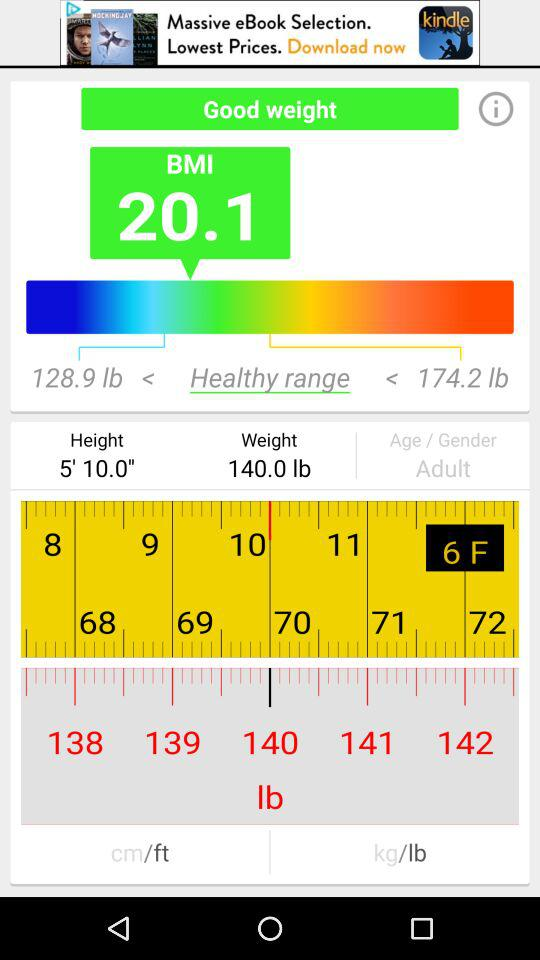What is the given BMI? The given BMI is 20.1. 